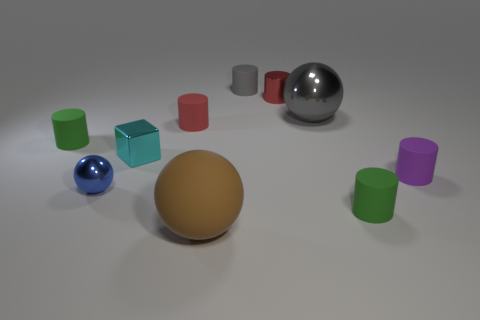The small red thing that is right of the brown object has what shape?
Ensure brevity in your answer.  Cylinder. Do the ball that is behind the metallic block and the rubber cylinder that is behind the large gray sphere have the same color?
Offer a very short reply. Yes. How many small objects are both left of the small purple matte cylinder and in front of the tiny gray cylinder?
Offer a terse response. 6. What is the size of the cylinder that is made of the same material as the small cyan cube?
Ensure brevity in your answer.  Small. How big is the red metal cylinder?
Give a very brief answer. Small. What is the large gray thing made of?
Your answer should be very brief. Metal. Do the gray thing that is to the right of the red shiny cylinder and the gray rubber cylinder have the same size?
Ensure brevity in your answer.  No. How many things are either small brown cylinders or small red rubber cylinders?
Ensure brevity in your answer.  1. The small thing that is the same color as the small shiny cylinder is what shape?
Give a very brief answer. Cylinder. How big is the metallic object that is behind the purple cylinder and to the left of the big brown rubber sphere?
Give a very brief answer. Small. 